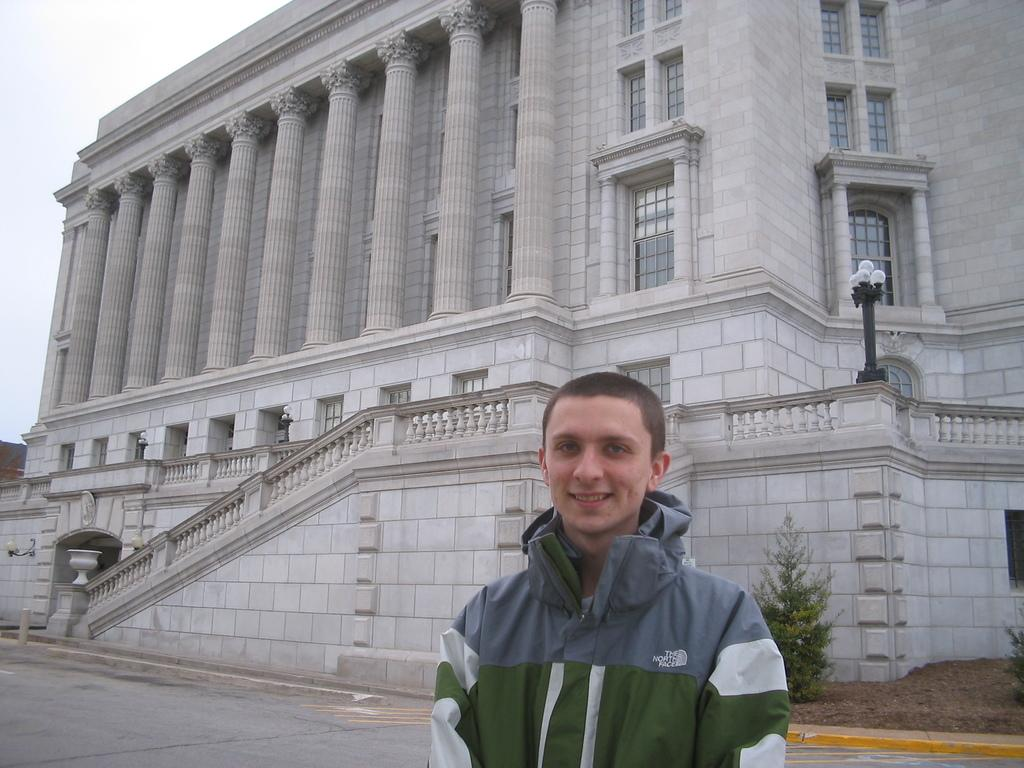<image>
Provide a brief description of the given image. The boy has on a North Face jacket standing in front of a historic building. 